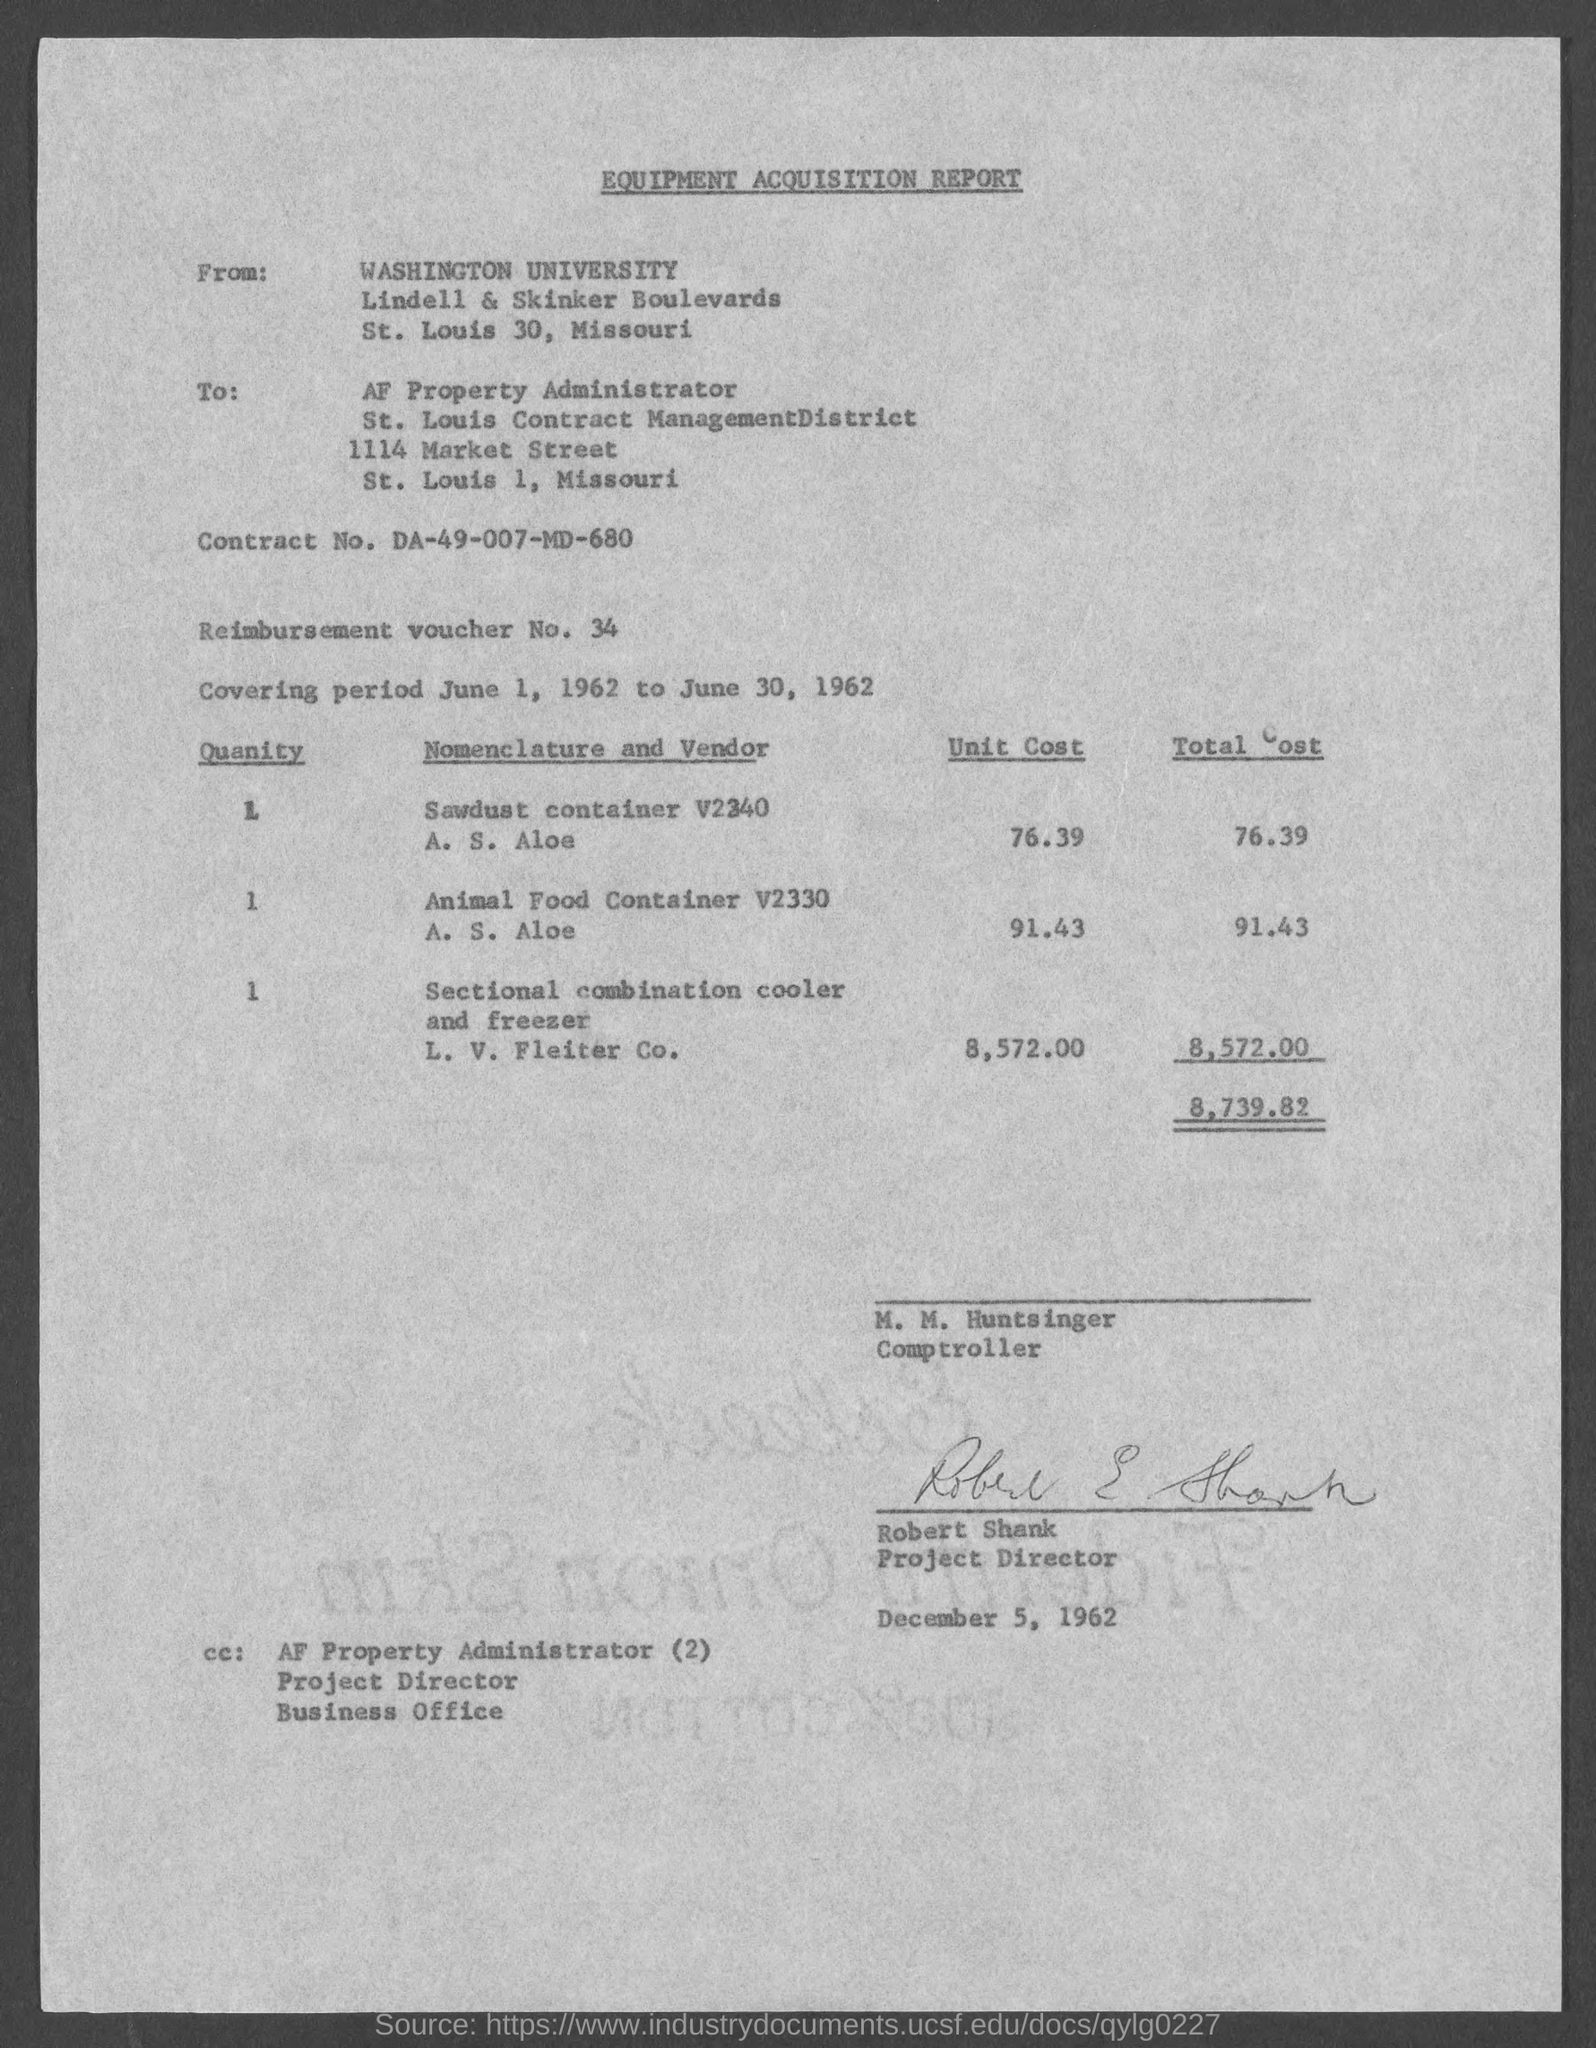What is the Title of the Report?
Your answer should be very brief. EQUIPMENT ACQUISITION REPORT. To whom report is written?
Your answer should be very brief. AF Property Administrator. Who is the Project Director?
Your answer should be compact. Robert Shank. What is Contract No.?
Ensure brevity in your answer.  DA-49-007-MD-680. 